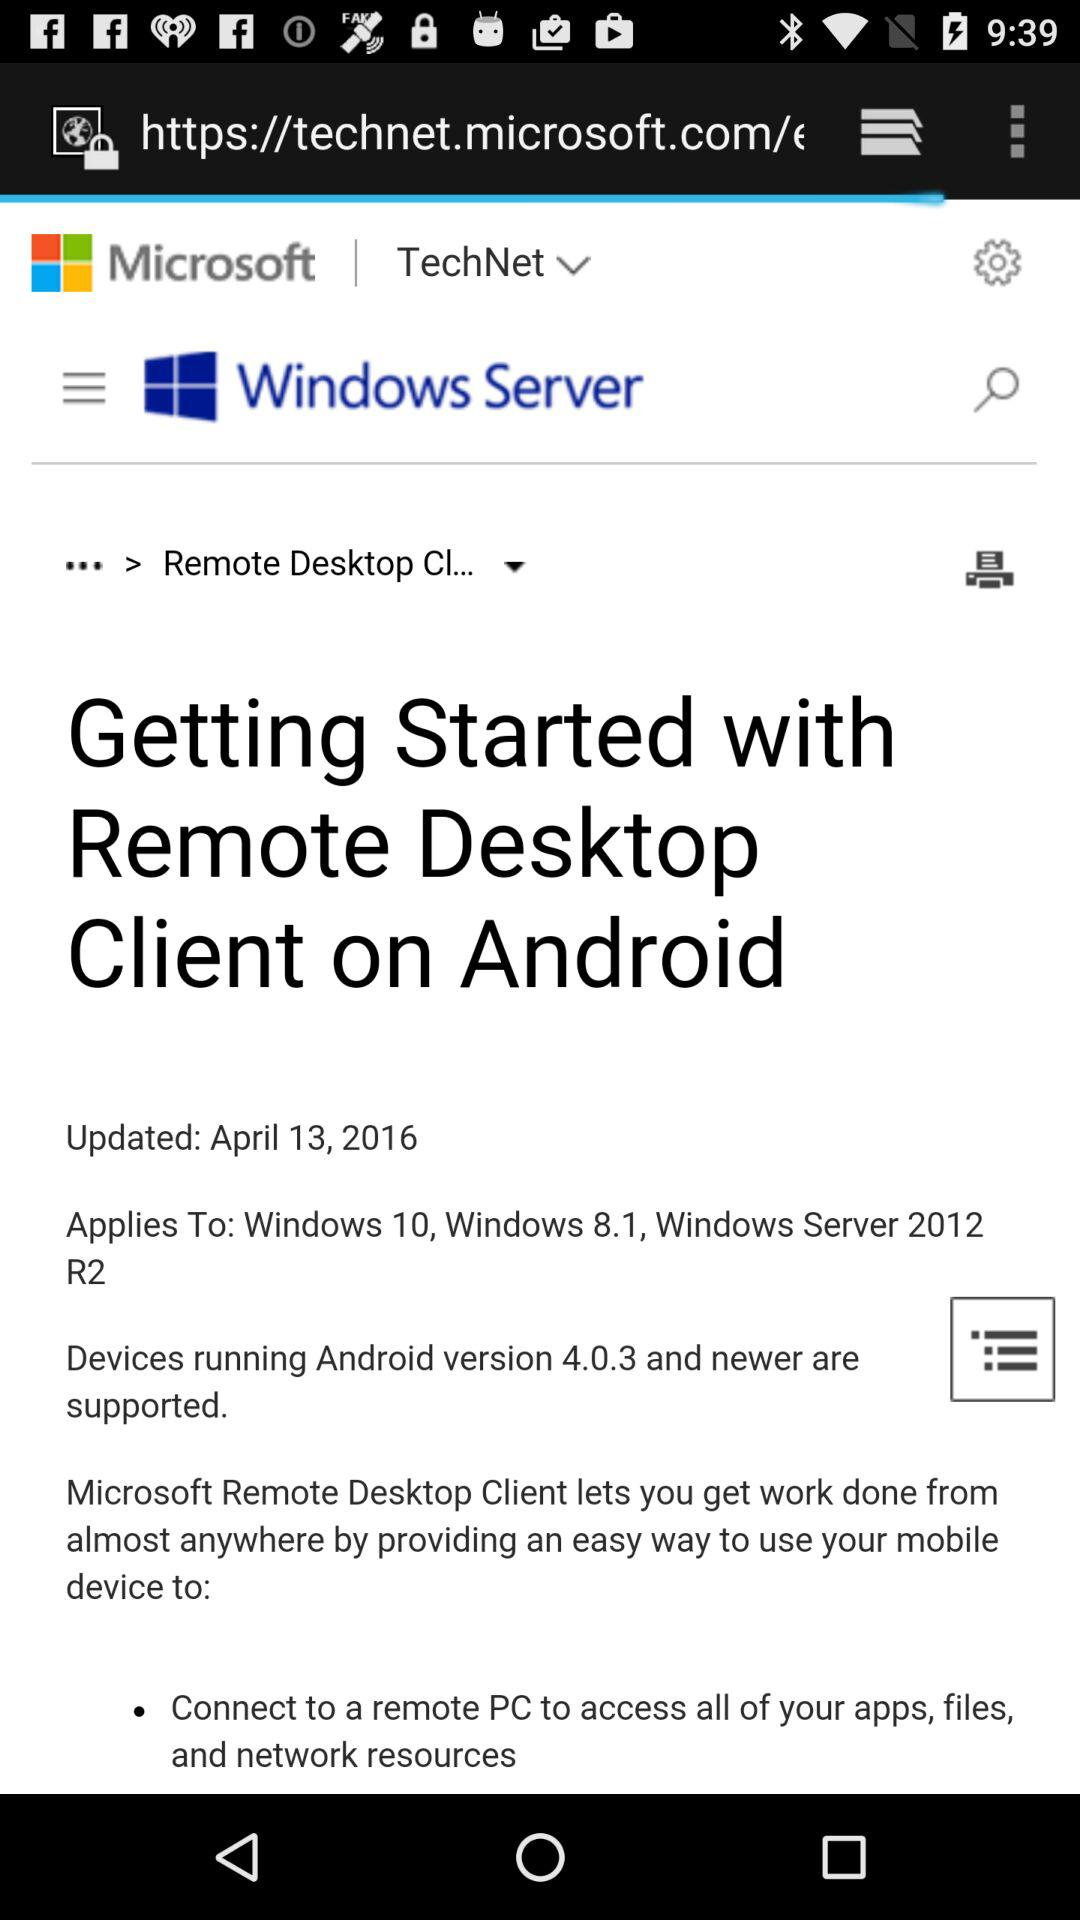What is the headline? The headline is "Getting Started with Remote Desktop Client on Android". 